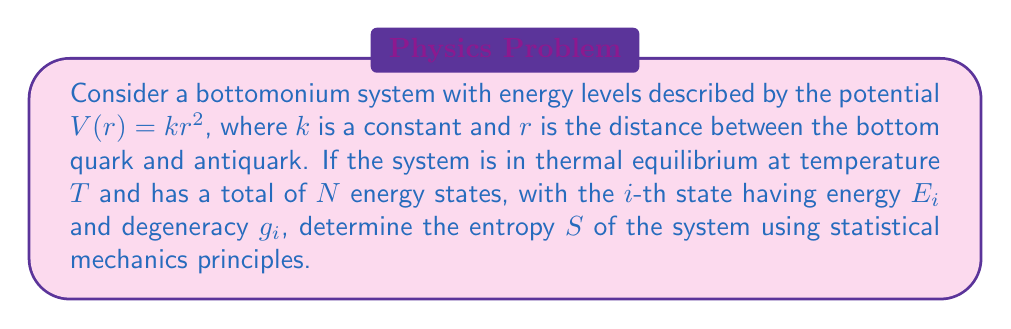Help me with this question. To determine the entropy of the bottomonium system, we'll follow these steps:

1) First, recall the general expression for entropy in statistical mechanics:

   $$S = -k_B \sum_i p_i \ln p_i$$

   where $k_B$ is Boltzmann's constant and $p_i$ is the probability of the system being in the $i$-th state.

2) For a system in thermal equilibrium, the probability of being in a state with energy $E_i$ is given by the Boltzmann distribution:

   $$p_i = \frac{g_i e^{-E_i/k_BT}}{Z}$$

   where $Z$ is the partition function.

3) The partition function $Z$ is defined as:

   $$Z = \sum_i g_i e^{-E_i/k_BT}$$

4) Substituting the expression for $p_i$ into the entropy formula:

   $$S = -k_B \sum_i \frac{g_i e^{-E_i/k_BT}}{Z} \ln \left(\frac{g_i e^{-E_i/k_BT}}{Z}\right)$$

5) Expanding the logarithm:

   $$S = -k_B \sum_i \frac{g_i e^{-E_i/k_BT}}{Z} \left[\ln(g_i) - \frac{E_i}{k_BT} - \ln(Z)\right]$$

6) Simplify:

   $$S = -k_B \sum_i \frac{g_i e^{-E_i/k_BT}}{Z} \ln(g_i) + \frac{1}{T} \sum_i \frac{g_i E_i e^{-E_i/k_BT}}{Z} + k_B \ln(Z)$$

7) Recognize that $\sum_i p_i = 1$, so the last term simplifies to $k_B \ln(Z)$.

8) The middle term can be written as $\langle E \rangle / T$, where $\langle E \rangle$ is the average energy of the system.

9) Therefore, the final expression for entropy is:

   $$S = k_B \ln(Z) + \frac{\langle E \rangle}{T} - k_B \sum_i p_i \ln(g_i)$$

This is known as the Gibbs entropy formula.
Answer: $S = k_B \ln(Z) + \frac{\langle E \rangle}{T} - k_B \sum_i p_i \ln(g_i)$ 